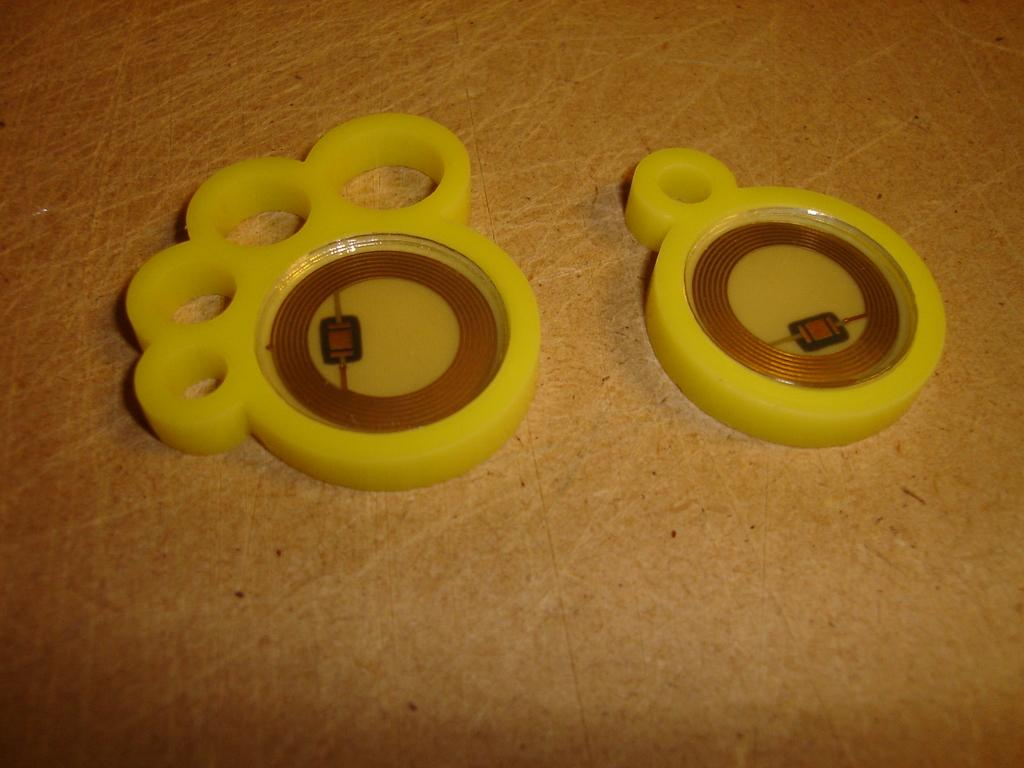How many objects are visible in the image? There are two objects in the image. Where are the objects located? The objects are on the floor. What color are the objects? The objects are yellow in color. What type of produce is being delivered to the mailbox in the image? There is no produce or mailbox present in the image; it only features two yellow objects on the floor. 